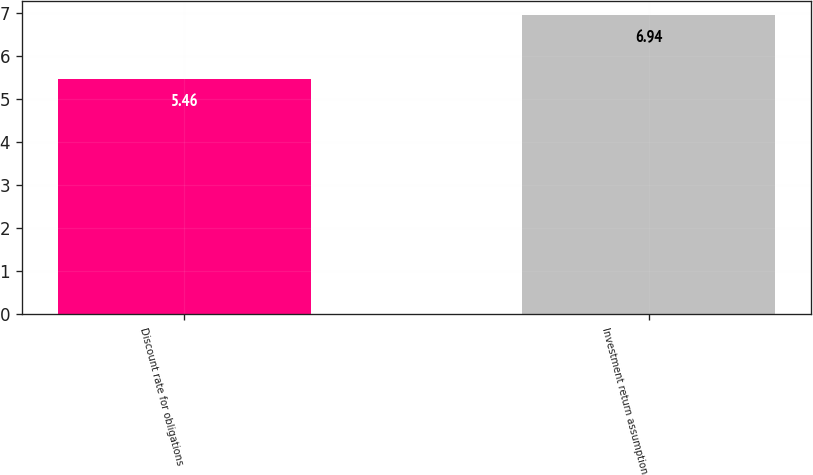Convert chart to OTSL. <chart><loc_0><loc_0><loc_500><loc_500><bar_chart><fcel>Discount rate for obligations<fcel>Investment return assumption<nl><fcel>5.46<fcel>6.94<nl></chart> 